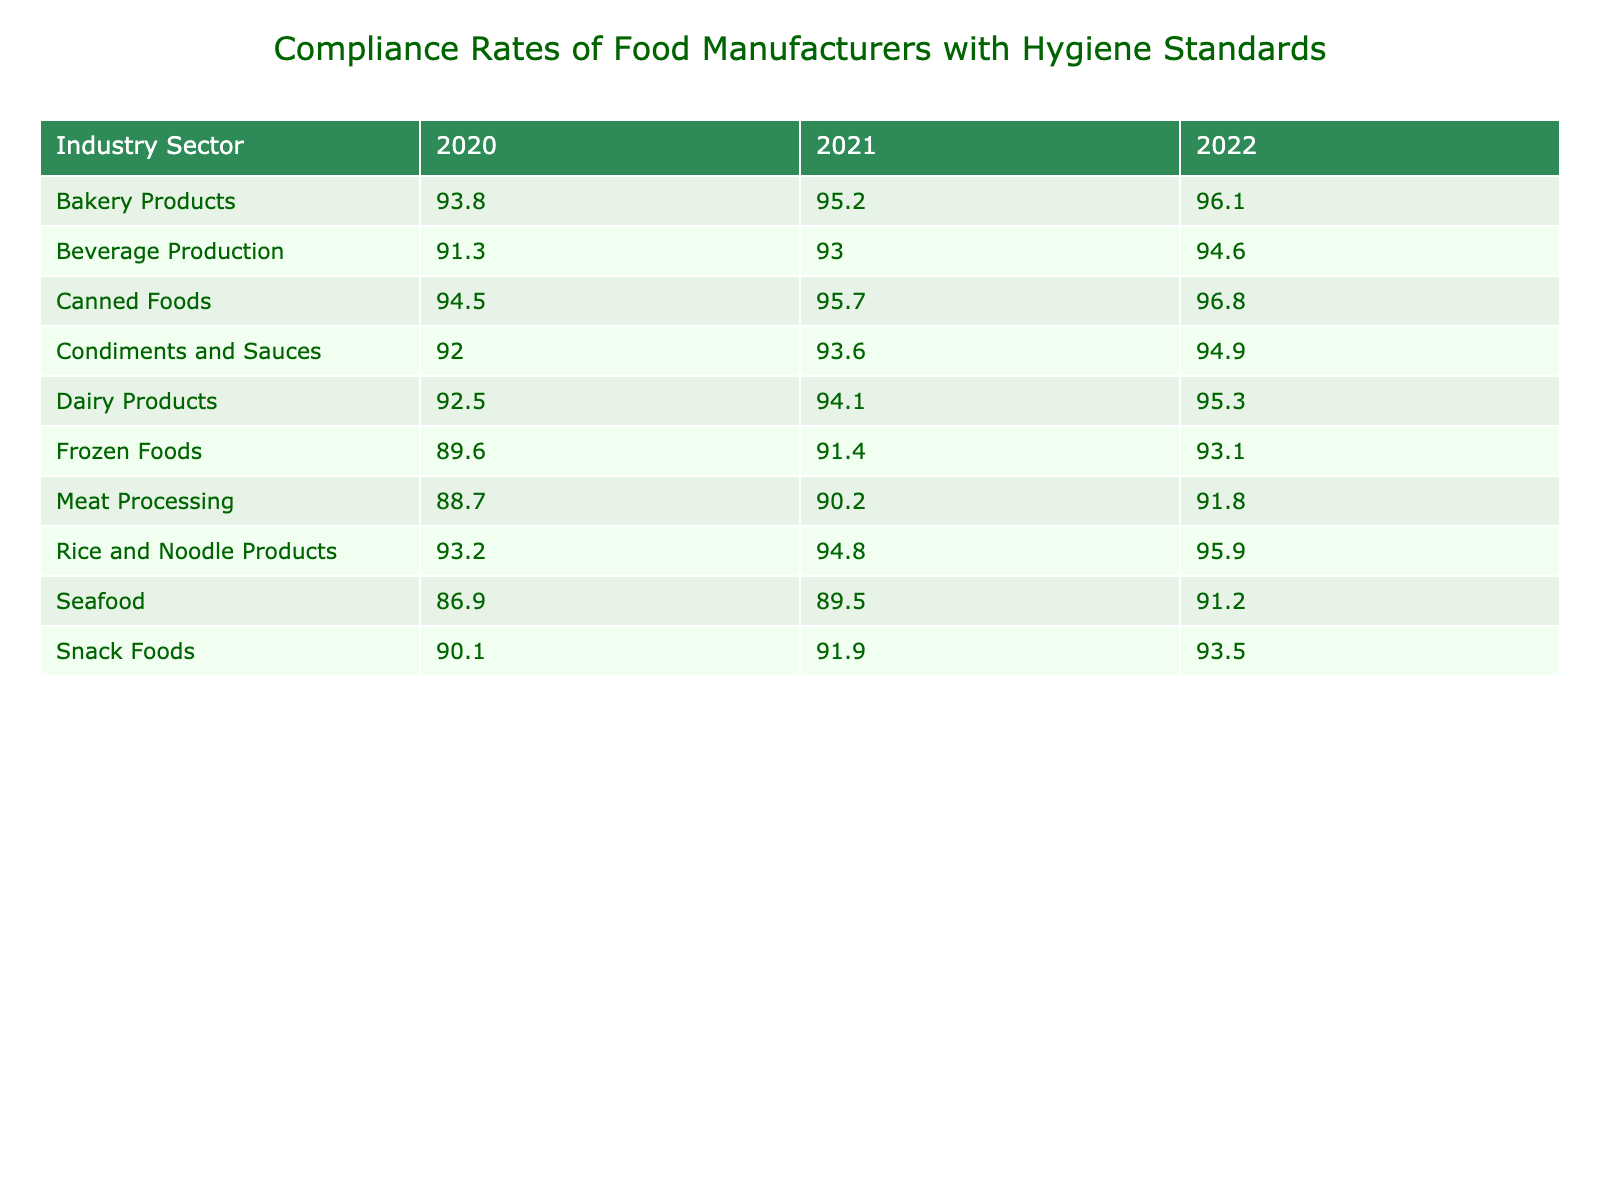What was the compliance rate for Dairy Products in 2022? By locating the "Dairy Products" row and the "2022" column in the table, we can directly find the value of the compliance rate for that year, which is 95.3.
Answer: 95.3 Which industry sector had the lowest compliance rate in 2020? By examining the values for the year 2020 across all industry sectors, the lowest number is for "Seafood" at 86.9.
Answer: Seafood What is the average compliance rate for Meat Processing over the three years? The compliance rates for Meat Processing are 88.7, 90.2, and 91.8. The sum is 88.7 + 90.2 + 91.8 = 270.7, and with three data points, the average is 270.7 / 3 = 90.23.
Answer: 90.23 Did the compliance rate for Canned Foods increase every year? We check the compliance rates for Canned Foods across the years: 2020 (94.5), 2021 (95.7), and 2022 (96.8). Since each year’s rate is greater than the previous year, the compliance rate did increase every year.
Answer: Yes Which industry sector had the highest compliance rate in 2021? We look through the 2021 compliance rates for all sectors and find that "Bakery Products" has the highest rate at 95.2.
Answer: Bakery Products What was the difference in compliance rates between Frozen Foods in 2020 and 2022? The compliance rates are 89.6 for 2020 and 93.1 for 2022. The difference is calculated as 93.1 - 89.6 = 3.5.
Answer: 3.5 Is it true that Beverage Production had a compliance rate below 90% in any of the years? Checking the values for Beverage Production: 2020 (91.3), 2021 (93.0), and 2022 (94.6), all the rates are above 90%. Therefore, it is not true that it fell below 90%.
Answer: No Which sector showed the greatest improvement in compliance rate from 2020 to 2022? We calculate the improvement for each sector by subtracting the 2020 value from the 2022 value. For example, Dairy Products improved by (95.3 - 92.5) = 2.8, Bakery Products by (96.1 - 93.8) = 2.3, and Canned Foods by (96.8 - 94.5) = 2.3. The greatest improvement is for Dairy Products at 2.8.
Answer: Dairy Products What was the compliance rate for Rice and Noodle Products in 2021? By looking at the row for Rice and Noodle Products and locating the 2021 column, the compliance rate is found to be 94.8.
Answer: 94.8 Are Seafood compliance rates in 2021 and 2022 higher than 90%? The rates for Seafood are 89.5 in 2021 and 91.2 in 2022. Therefore, while 2022 is above 90%, 2021 is not, meaning not both years are above 90%.
Answer: No 